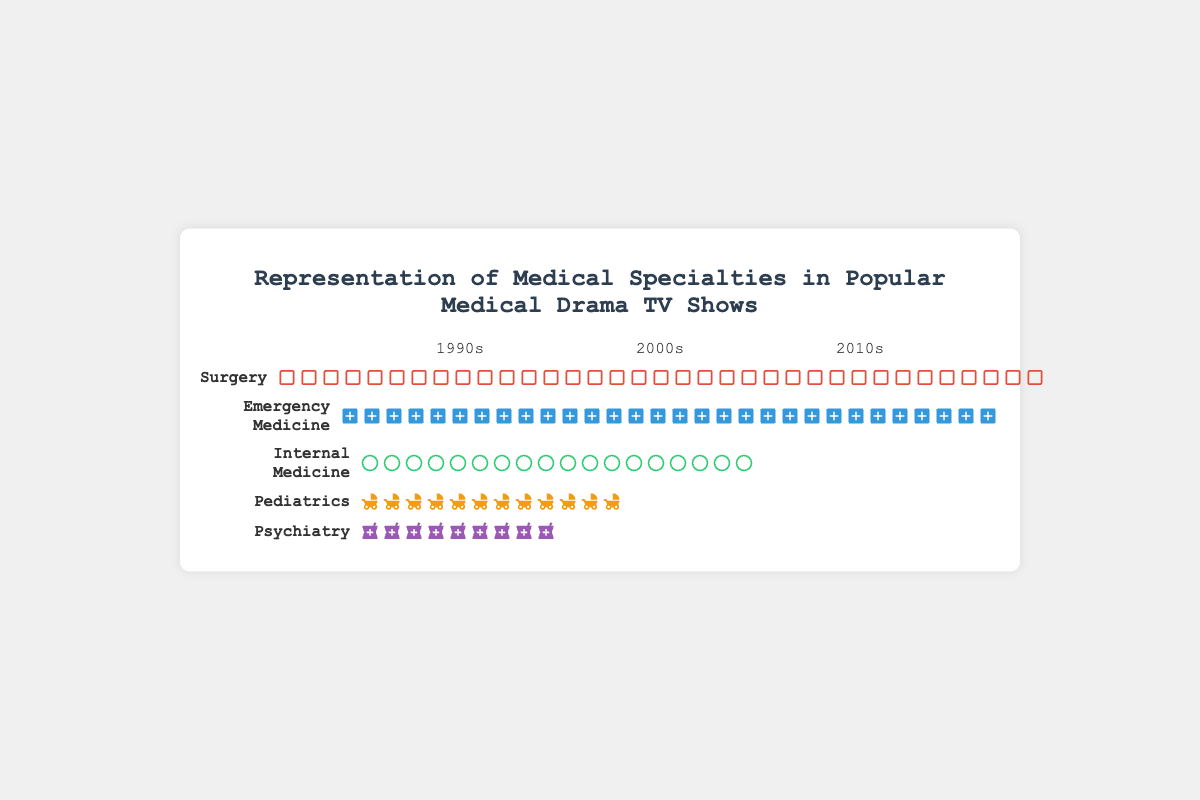What is the title of the figure? The title of the figure is displayed at the top and summarizes the topic it covers. It is prominently placed and easy to identify in most visual representations.
Answer: Representation of Medical Specialties in Popular Medical Drama TV Shows Which specialty had the highest representation in the 2010s? To determine this, we need to visually assess the icons representing each specialty in the 2010s column, counting the icons for each specialty.
Answer: Surgery How did the representation of Pediatrics change from the 1990s to the 2010s? Compare the number of icons representing Pediatrics in the 1990s with those in the 2010s.
Answer: It increased by 4 icons Which decade had the highest overall representation of Emergency Medicine? Look at all decades and count the number of icons representing Emergency Medicine in each decade, then compare.
Answer: 2010s Was Psychiatry more represented in the 2000s or the 1990s? Compare the number of icons for Psychiatry in the 2000s with those in the 1990s.
Answer: 2000s Add up the total representations for Internal Medicine across all decades. Count the number of icons for Internal Medicine in each decade and then sum the counts across the 1990s, 2000s, and 2010s.
Answer: 18 Which specialty showed a consistent increase in representation across all three decades? Examine each specialty's icon counts for the 1990s, 2000s, and 2010s to determine if the counts increase sequentially.
Answer: All specialties How many more icons of Surgery are there in the 2010s compared to the 1990s? Subtract the number of Surgery icons in the 1990s from the number in the 2010s.
Answer: 7 If we sum the representations of Surgery and Emergency Medicine in the 2000s, what is the total? Add the number of icons representing Surgery and Emergency Medicine in the 2000s column.
Answer: 22 Comparing Pediatrics and Psychiatry in the 2010s, which had more representations and by how many? Count the number of icons for both Pediatrics and Psychiatry in the 2010s and then subtract the smaller count from the larger.
Answer: Pediatrics by 1 